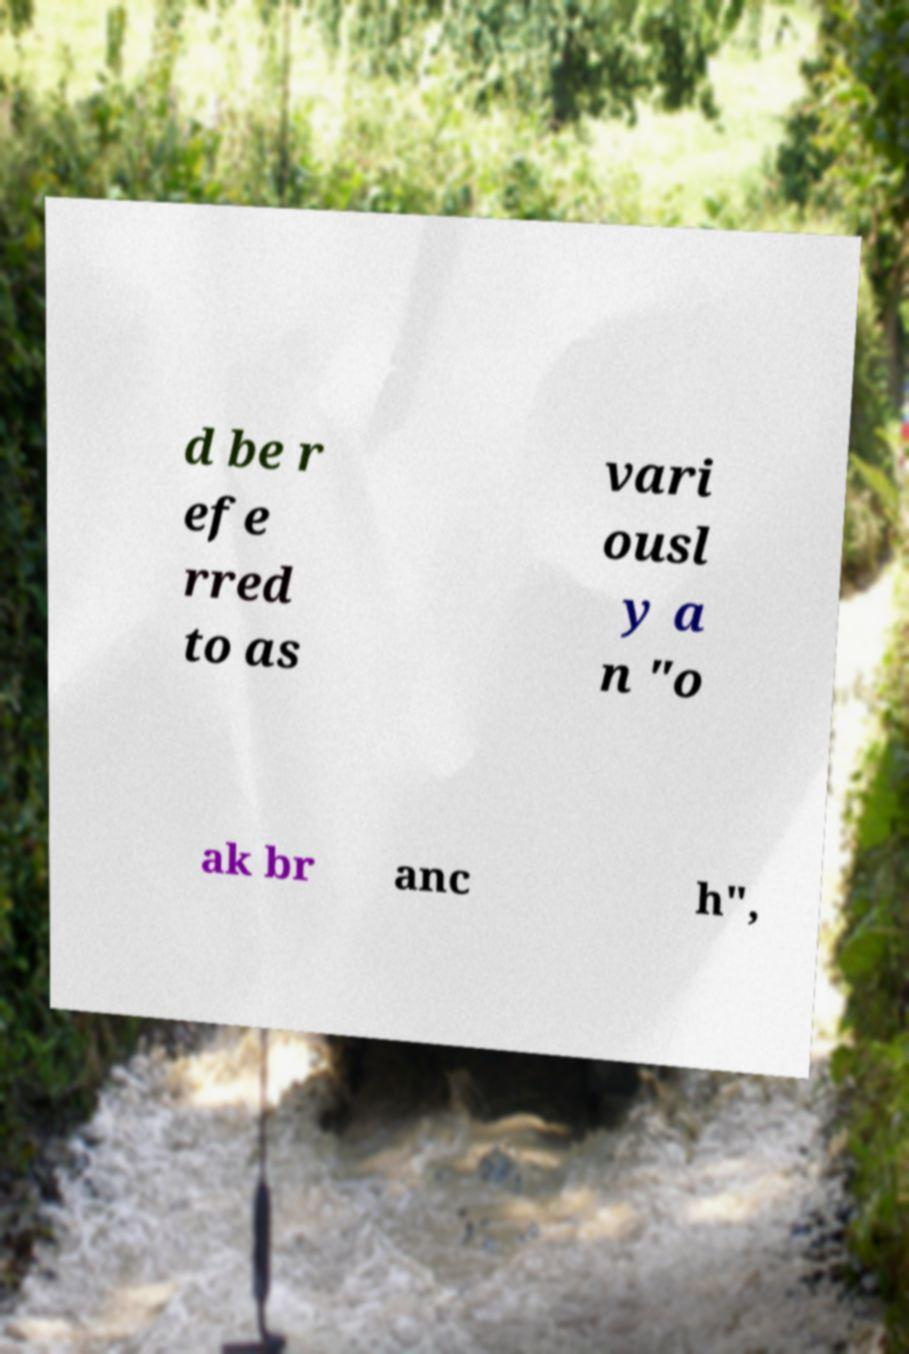Please identify and transcribe the text found in this image. d be r efe rred to as vari ousl y a n "o ak br anc h", 